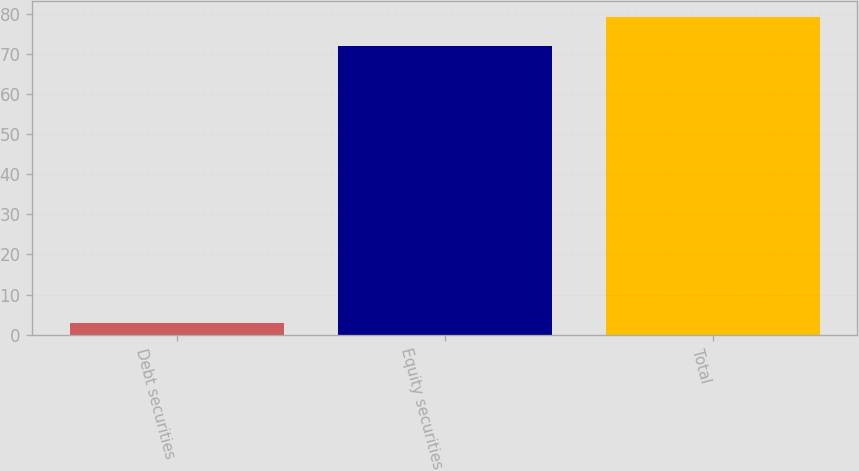<chart> <loc_0><loc_0><loc_500><loc_500><bar_chart><fcel>Debt securities<fcel>Equity securities<fcel>Total<nl><fcel>3<fcel>72<fcel>79.2<nl></chart> 